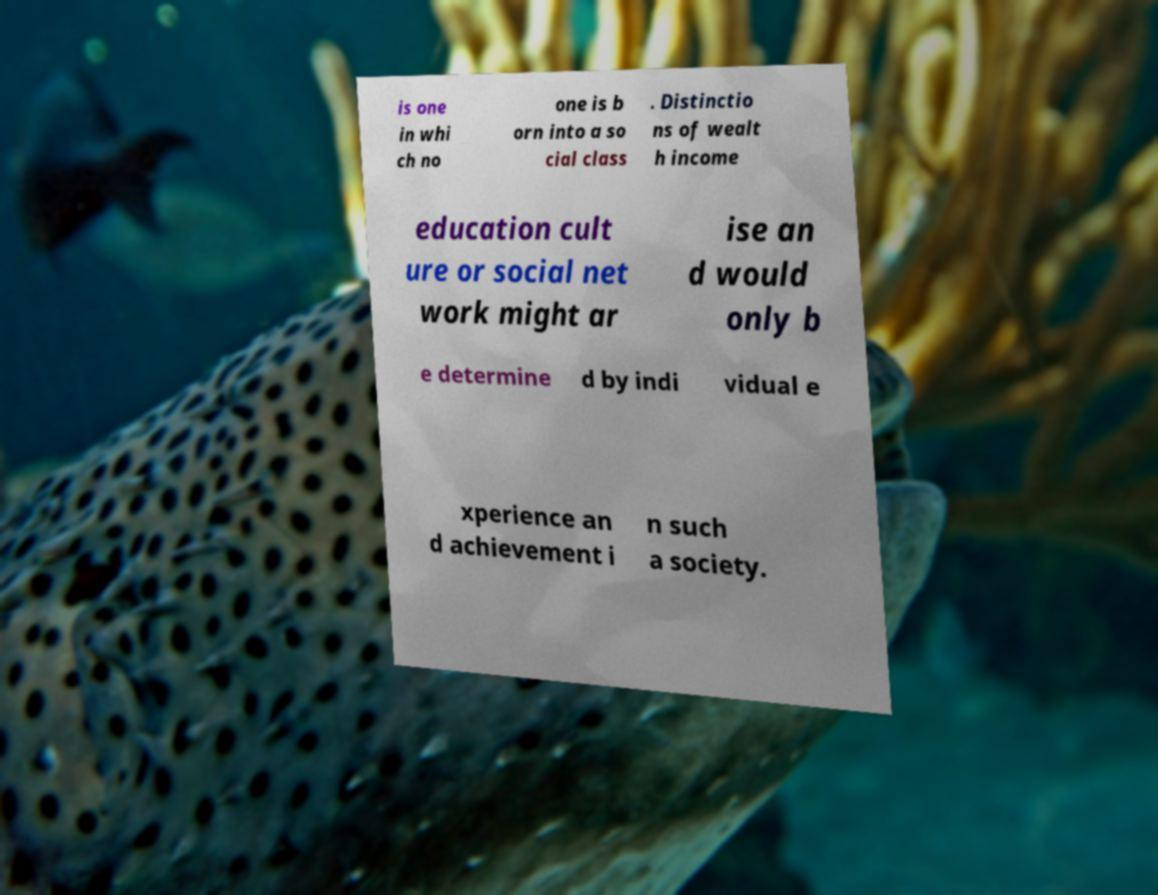I need the written content from this picture converted into text. Can you do that? is one in whi ch no one is b orn into a so cial class . Distinctio ns of wealt h income education cult ure or social net work might ar ise an d would only b e determine d by indi vidual e xperience an d achievement i n such a society. 